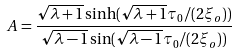Convert formula to latex. <formula><loc_0><loc_0><loc_500><loc_500>A = \frac { \sqrt { \lambda + 1 } \sinh ( \sqrt { \lambda + 1 } \tau _ { 0 } / ( 2 \xi _ { o } ) ) } { \sqrt { \lambda - 1 } \sin ( \sqrt { \lambda - 1 } \tau _ { 0 } / ( 2 \xi _ { o } ) ) }</formula> 